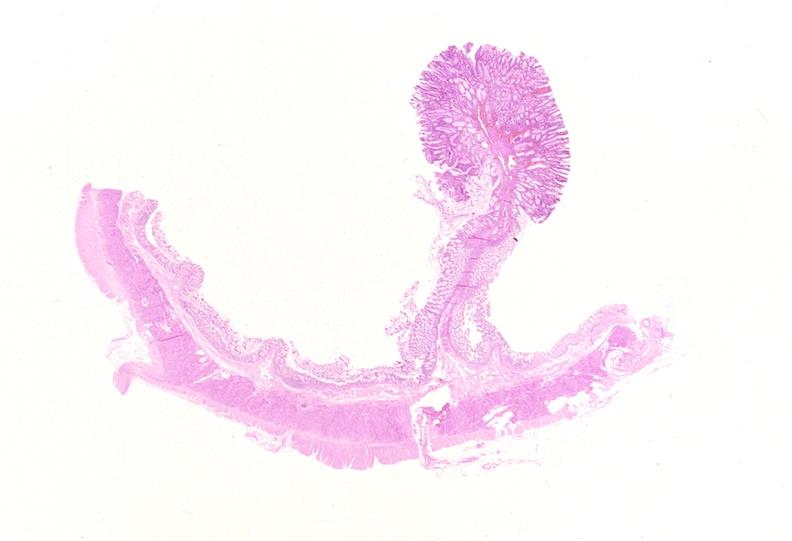does acid show colon, adenomatous polyp?
Answer the question using a single word or phrase. No 